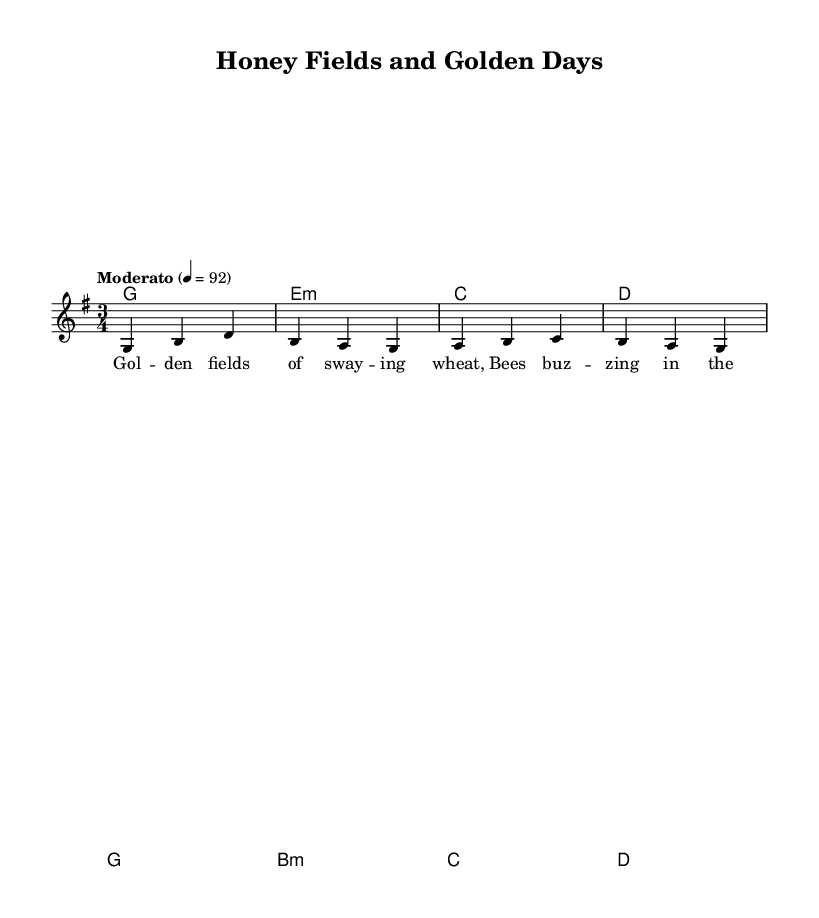What is the key signature of this music? The key signature shown in the music is G major, which has one sharp (F sharp). This can be determined by looking at the key signature indicated at the beginning of the score.
Answer: G major What is the time signature of this music? The time signature indicated in the score is 3/4, which means there are three beats per measure and a quarter note gets one beat. This can be found at the beginning of the sheet music.
Answer: 3/4 What is the tempo marking for this piece? The tempo marking in the music states "Moderato" with a metronome marking of 92 beats per minute. This is indicated at the beginning of the score and informs the performer how quickly to play the piece.
Answer: Moderato 4 = 92 How many measures are there in the melody section? By counting the distinct measure segments in the melody part, there are four measures shown. This can be deduced from the number of bars notated in the melody.
Answer: 4 What chord is played on the first measure? The first measure features a G major chord as represented by the harmonic notation. The chord under the melody corresponds to the note G, which is the tonality established at the beginning.
Answer: G What is the lyrical theme of this piece? The lyrics signify a celebration of rural life, mentioning "golden fields" and "bees buzzing," which reflect a pastoral and nostalgic theme focused on nature and farming. This thematic connection can be inferred from the lyrics provided.
Answer: Nostalgic rural celebration What musical texture is prevalent in this piece? The score includes various harmonic chords and a single melodic line in the staff, indicating a homophonic texture where the melody is supported by the harmony. This can be observed by recognizing the arrangement of chords and melody.
Answer: Homophonic 